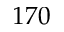<formula> <loc_0><loc_0><loc_500><loc_500>1 7 0</formula> 